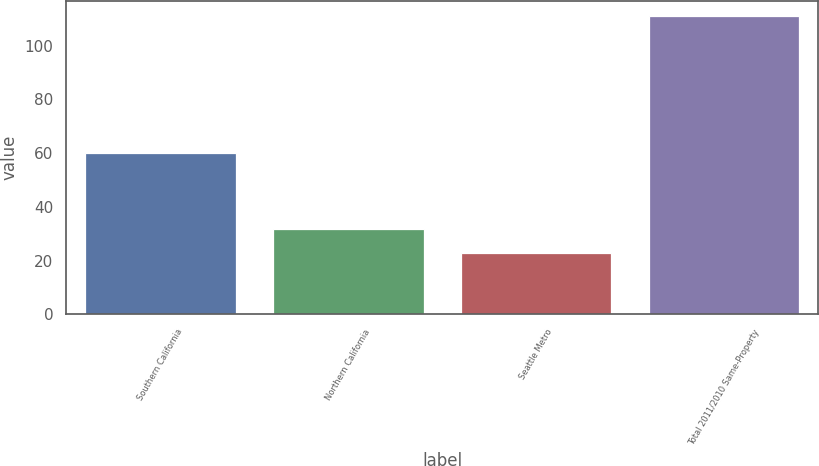Convert chart to OTSL. <chart><loc_0><loc_0><loc_500><loc_500><bar_chart><fcel>Southern California<fcel>Northern California<fcel>Seattle Metro<fcel>Total 2011/2010 Same-Property<nl><fcel>60<fcel>31.8<fcel>23<fcel>111<nl></chart> 